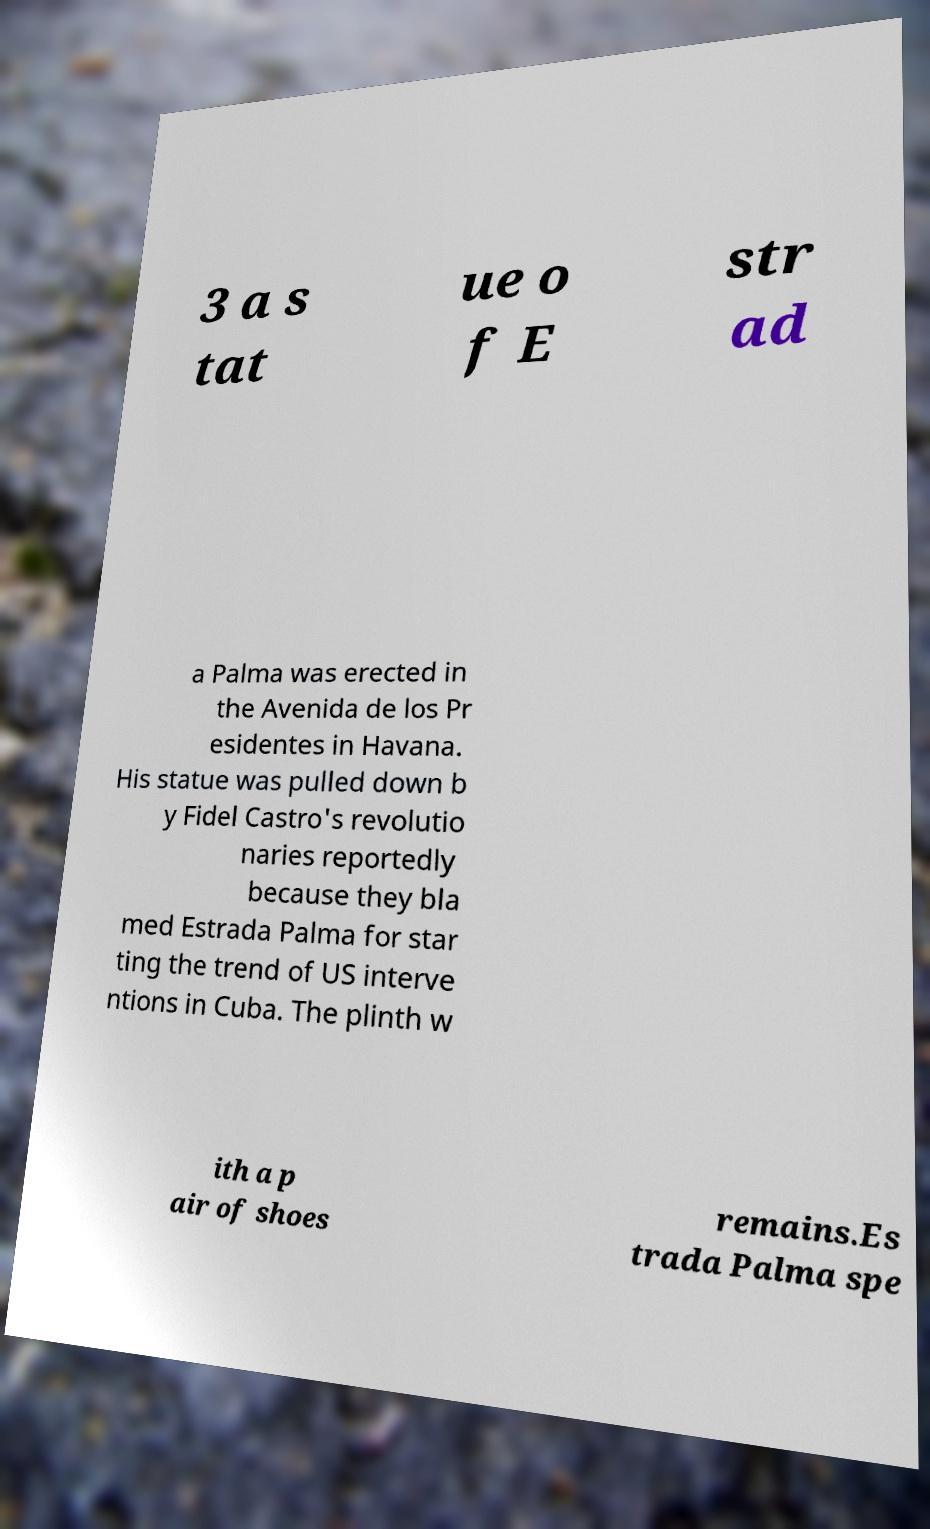Could you extract and type out the text from this image? 3 a s tat ue o f E str ad a Palma was erected in the Avenida de los Pr esidentes in Havana. His statue was pulled down b y Fidel Castro's revolutio naries reportedly because they bla med Estrada Palma for star ting the trend of US interve ntions in Cuba. The plinth w ith a p air of shoes remains.Es trada Palma spe 